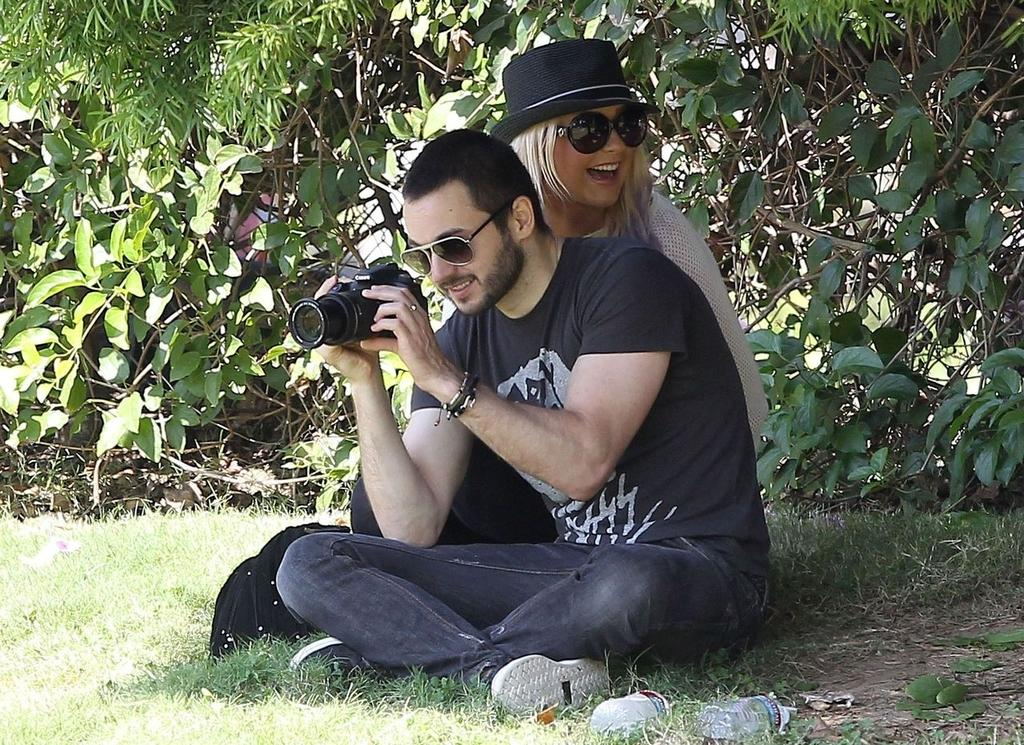How many people are present in the image? There are two people in the image, a man and a woman. What is the man holding in his hands? The man is holding a camera in his hands. What can be seen in the background of the image? There are plants in the backdrop of the image. What type of muscle is the woman flexing in the image? There is no indication in the image that the woman is flexing any muscles. 